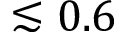Convert formula to latex. <formula><loc_0><loc_0><loc_500><loc_500>\lesssim 0 . 6</formula> 